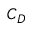<formula> <loc_0><loc_0><loc_500><loc_500>C _ { D }</formula> 